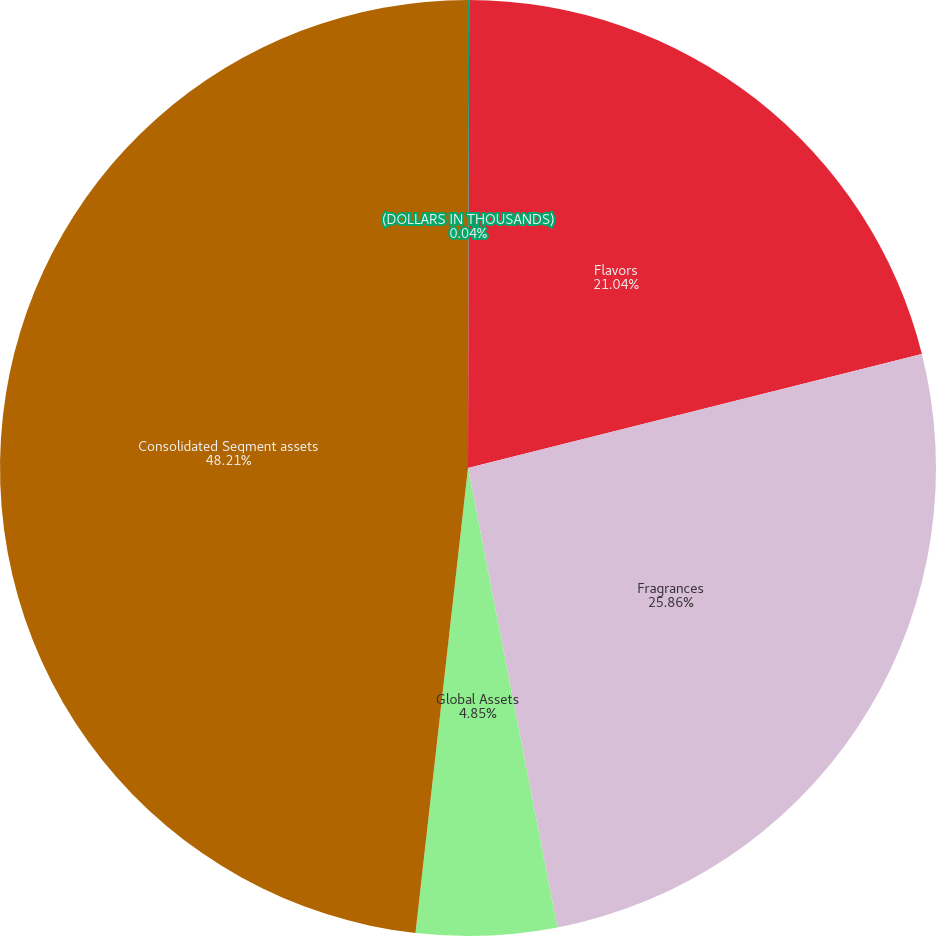<chart> <loc_0><loc_0><loc_500><loc_500><pie_chart><fcel>(DOLLARS IN THOUSANDS)<fcel>Flavors<fcel>Fragrances<fcel>Global Assets<fcel>Consolidated Segment assets<nl><fcel>0.04%<fcel>21.04%<fcel>25.86%<fcel>4.85%<fcel>48.21%<nl></chart> 